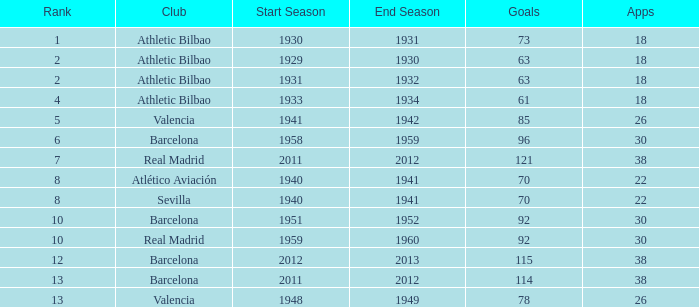What season was Barcelona ranked higher than 12, had more than 96 goals and had more than 26 apps? 2011/12. 